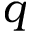Convert formula to latex. <formula><loc_0><loc_0><loc_500><loc_500>q</formula> 